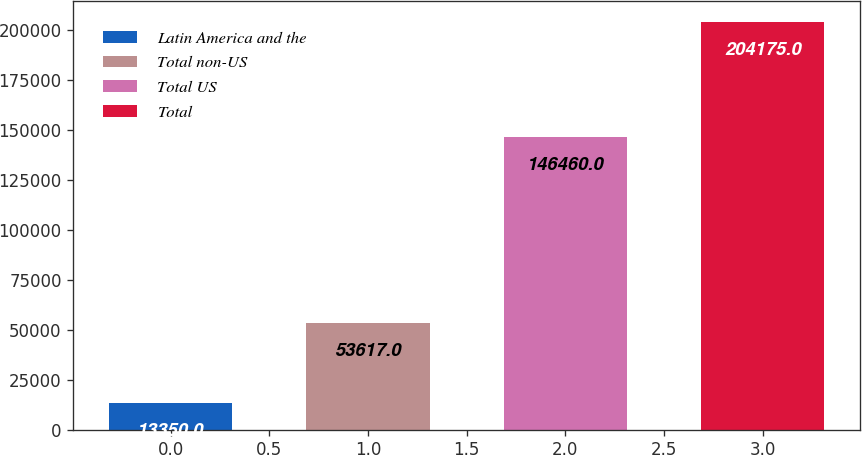<chart> <loc_0><loc_0><loc_500><loc_500><bar_chart><fcel>Latin America and the<fcel>Total non-US<fcel>Total US<fcel>Total<nl><fcel>13350<fcel>53617<fcel>146460<fcel>204175<nl></chart> 